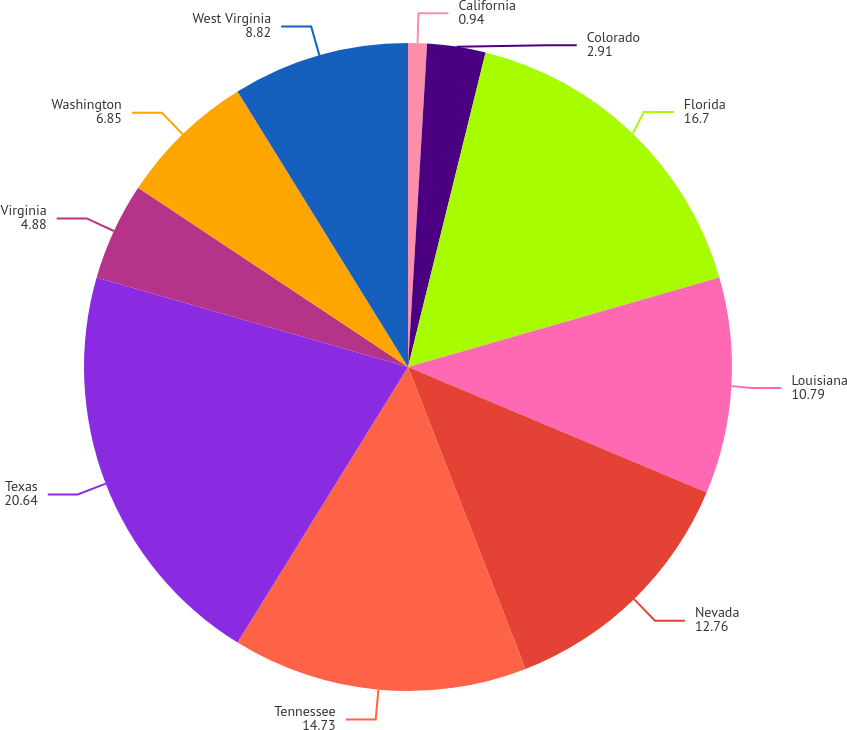Convert chart. <chart><loc_0><loc_0><loc_500><loc_500><pie_chart><fcel>California<fcel>Colorado<fcel>Florida<fcel>Louisiana<fcel>Nevada<fcel>Tennessee<fcel>Texas<fcel>Virginia<fcel>Washington<fcel>West Virginia<nl><fcel>0.94%<fcel>2.91%<fcel>16.7%<fcel>10.79%<fcel>12.76%<fcel>14.73%<fcel>20.64%<fcel>4.88%<fcel>6.85%<fcel>8.82%<nl></chart> 